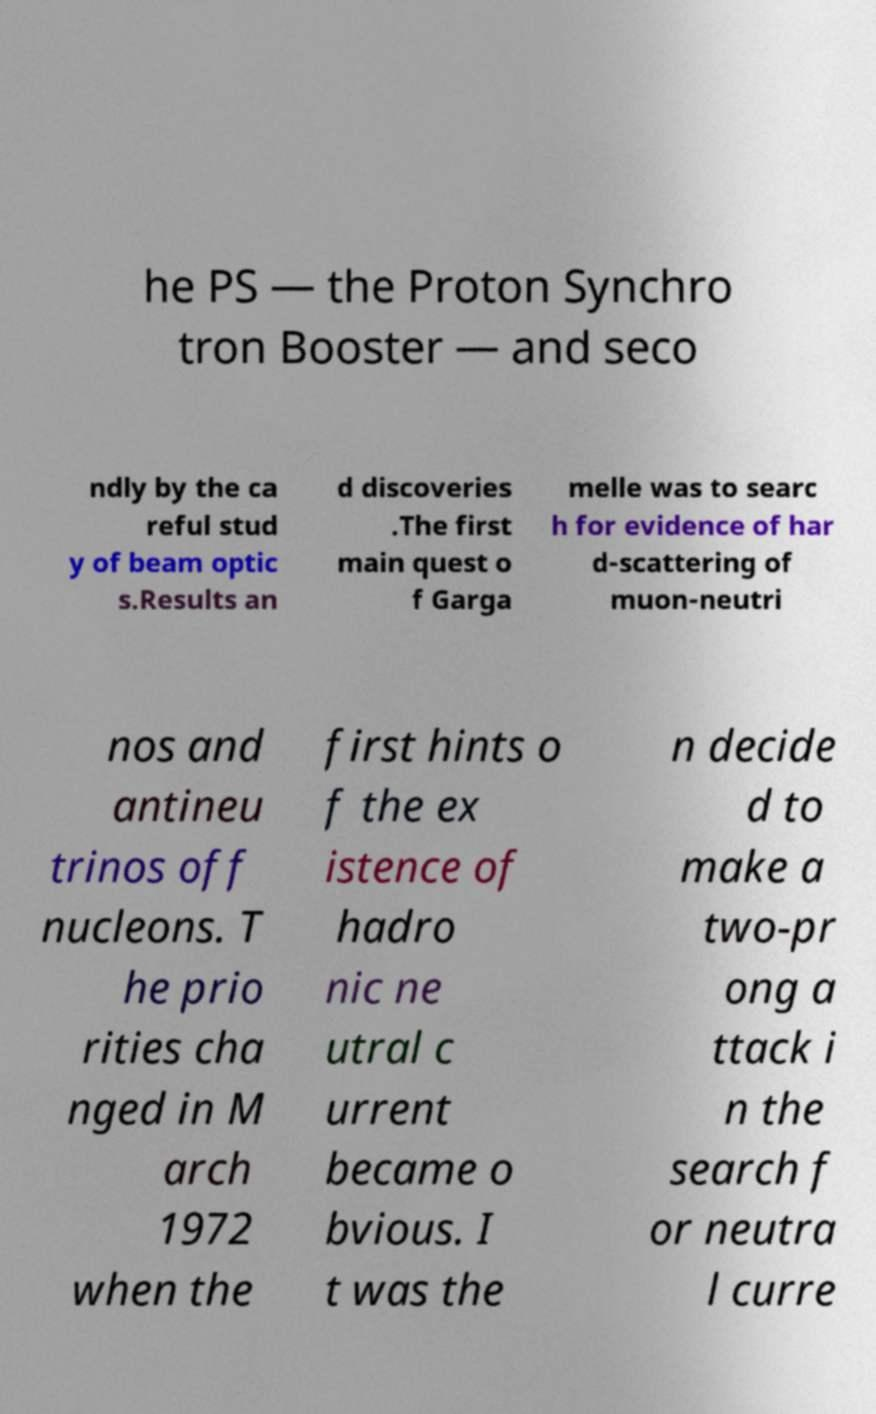Could you assist in decoding the text presented in this image and type it out clearly? he PS — the Proton Synchro tron Booster — and seco ndly by the ca reful stud y of beam optic s.Results an d discoveries .The first main quest o f Garga melle was to searc h for evidence of har d-scattering of muon-neutri nos and antineu trinos off nucleons. T he prio rities cha nged in M arch 1972 when the first hints o f the ex istence of hadro nic ne utral c urrent became o bvious. I t was the n decide d to make a two-pr ong a ttack i n the search f or neutra l curre 